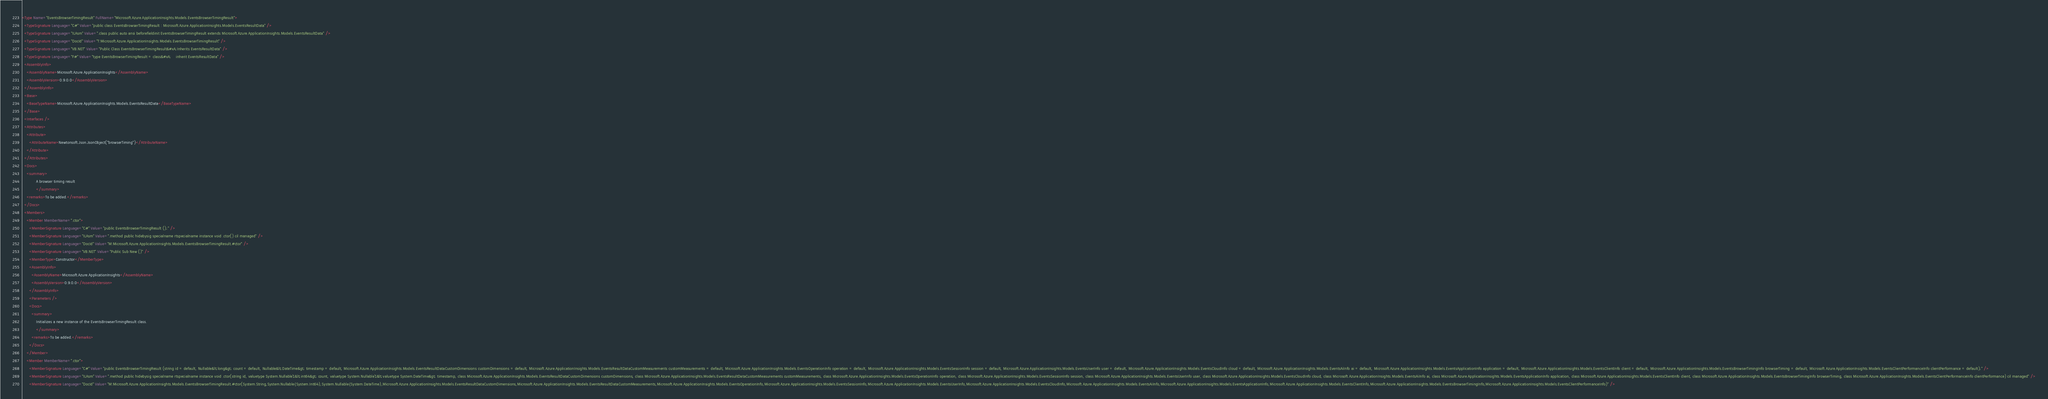Convert code to text. <code><loc_0><loc_0><loc_500><loc_500><_XML_><Type Name="EventsBrowserTimingResult" FullName="Microsoft.Azure.ApplicationInsights.Models.EventsBrowserTimingResult">
  <TypeSignature Language="C#" Value="public class EventsBrowserTimingResult : Microsoft.Azure.ApplicationInsights.Models.EventsResultData" />
  <TypeSignature Language="ILAsm" Value=".class public auto ansi beforefieldinit EventsBrowserTimingResult extends Microsoft.Azure.ApplicationInsights.Models.EventsResultData" />
  <TypeSignature Language="DocId" Value="T:Microsoft.Azure.ApplicationInsights.Models.EventsBrowserTimingResult" />
  <TypeSignature Language="VB.NET" Value="Public Class EventsBrowserTimingResult&#xA;Inherits EventsResultData" />
  <TypeSignature Language="F#" Value="type EventsBrowserTimingResult = class&#xA;    inherit EventsResultData" />
  <AssemblyInfo>
    <AssemblyName>Microsoft.Azure.ApplicationInsights</AssemblyName>
    <AssemblyVersion>0.9.0.0</AssemblyVersion>
  </AssemblyInfo>
  <Base>
    <BaseTypeName>Microsoft.Azure.ApplicationInsights.Models.EventsResultData</BaseTypeName>
  </Base>
  <Interfaces />
  <Attributes>
    <Attribute>
      <AttributeName>Newtonsoft.Json.JsonObject("browserTiming")</AttributeName>
    </Attribute>
  </Attributes>
  <Docs>
    <summary>
            A browser timing result
            </summary>
    <remarks>To be added.</remarks>
  </Docs>
  <Members>
    <Member MemberName=".ctor">
      <MemberSignature Language="C#" Value="public EventsBrowserTimingResult ();" />
      <MemberSignature Language="ILAsm" Value=".method public hidebysig specialname rtspecialname instance void .ctor() cil managed" />
      <MemberSignature Language="DocId" Value="M:Microsoft.Azure.ApplicationInsights.Models.EventsBrowserTimingResult.#ctor" />
      <MemberSignature Language="VB.NET" Value="Public Sub New ()" />
      <MemberType>Constructor</MemberType>
      <AssemblyInfo>
        <AssemblyName>Microsoft.Azure.ApplicationInsights</AssemblyName>
        <AssemblyVersion>0.9.0.0</AssemblyVersion>
      </AssemblyInfo>
      <Parameters />
      <Docs>
        <summary>
            Initializes a new instance of the EventsBrowserTimingResult class.
            </summary>
        <remarks>To be added.</remarks>
      </Docs>
    </Member>
    <Member MemberName=".ctor">
      <MemberSignature Language="C#" Value="public EventsBrowserTimingResult (string id = default, Nullable&lt;long&gt; count = default, Nullable&lt;DateTime&gt; timestamp = default, Microsoft.Azure.ApplicationInsights.Models.EventsResultDataCustomDimensions customDimensions = default, Microsoft.Azure.ApplicationInsights.Models.EventsResultDataCustomMeasurements customMeasurements = default, Microsoft.Azure.ApplicationInsights.Models.EventsOperationInfo operation = default, Microsoft.Azure.ApplicationInsights.Models.EventsSessionInfo session = default, Microsoft.Azure.ApplicationInsights.Models.EventsUserInfo user = default, Microsoft.Azure.ApplicationInsights.Models.EventsCloudInfo cloud = default, Microsoft.Azure.ApplicationInsights.Models.EventsAiInfo ai = default, Microsoft.Azure.ApplicationInsights.Models.EventsApplicationInfo application = default, Microsoft.Azure.ApplicationInsights.Models.EventsClientInfo client = default, Microsoft.Azure.ApplicationInsights.Models.EventsBrowserTimingInfo browserTiming = default, Microsoft.Azure.ApplicationInsights.Models.EventsClientPerformanceInfo clientPerformance = default);" />
      <MemberSignature Language="ILAsm" Value=".method public hidebysig specialname rtspecialname instance void .ctor(string id, valuetype System.Nullable`1&lt;int64&gt; count, valuetype System.Nullable`1&lt;valuetype System.DateTime&gt; timestamp, class Microsoft.Azure.ApplicationInsights.Models.EventsResultDataCustomDimensions customDimensions, class Microsoft.Azure.ApplicationInsights.Models.EventsResultDataCustomMeasurements customMeasurements, class Microsoft.Azure.ApplicationInsights.Models.EventsOperationInfo operation, class Microsoft.Azure.ApplicationInsights.Models.EventsSessionInfo session, class Microsoft.Azure.ApplicationInsights.Models.EventsUserInfo user, class Microsoft.Azure.ApplicationInsights.Models.EventsCloudInfo cloud, class Microsoft.Azure.ApplicationInsights.Models.EventsAiInfo ai, class Microsoft.Azure.ApplicationInsights.Models.EventsApplicationInfo application, class Microsoft.Azure.ApplicationInsights.Models.EventsClientInfo client, class Microsoft.Azure.ApplicationInsights.Models.EventsBrowserTimingInfo browserTiming, class Microsoft.Azure.ApplicationInsights.Models.EventsClientPerformanceInfo clientPerformance) cil managed" />
      <MemberSignature Language="DocId" Value="M:Microsoft.Azure.ApplicationInsights.Models.EventsBrowserTimingResult.#ctor(System.String,System.Nullable{System.Int64},System.Nullable{System.DateTime},Microsoft.Azure.ApplicationInsights.Models.EventsResultDataCustomDimensions,Microsoft.Azure.ApplicationInsights.Models.EventsResultDataCustomMeasurements,Microsoft.Azure.ApplicationInsights.Models.EventsOperationInfo,Microsoft.Azure.ApplicationInsights.Models.EventsSessionInfo,Microsoft.Azure.ApplicationInsights.Models.EventsUserInfo,Microsoft.Azure.ApplicationInsights.Models.EventsCloudInfo,Microsoft.Azure.ApplicationInsights.Models.EventsAiInfo,Microsoft.Azure.ApplicationInsights.Models.EventsApplicationInfo,Microsoft.Azure.ApplicationInsights.Models.EventsClientInfo,Microsoft.Azure.ApplicationInsights.Models.EventsBrowserTimingInfo,Microsoft.Azure.ApplicationInsights.Models.EventsClientPerformanceInfo)" /></code> 